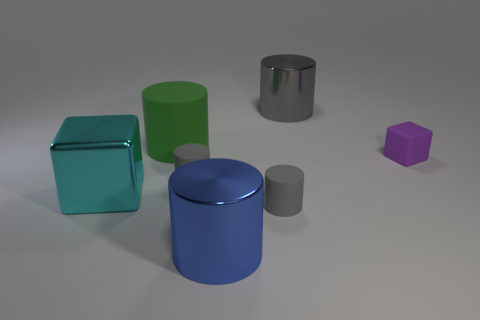Are there an equal number of cylinders that are in front of the large gray shiny thing and things in front of the tiny purple matte thing?
Provide a succinct answer. Yes. How many blue objects are either big cubes or large cylinders?
Give a very brief answer. 1. How many blue metal cylinders have the same size as the green object?
Offer a very short reply. 1. What is the color of the cylinder that is both to the right of the big blue metal object and behind the cyan metallic block?
Your answer should be compact. Gray. Are there more rubber cylinders in front of the purple rubber thing than small cubes?
Your answer should be very brief. Yes. Are any large purple cylinders visible?
Make the answer very short. No. How many small things are either blue metallic cylinders or blue blocks?
Give a very brief answer. 0. There is a large cyan thing that is the same material as the big gray thing; what is its shape?
Make the answer very short. Cube. There is a block that is right of the large rubber cylinder; how big is it?
Your response must be concise. Small. The tiny purple rubber thing has what shape?
Your response must be concise. Cube. 